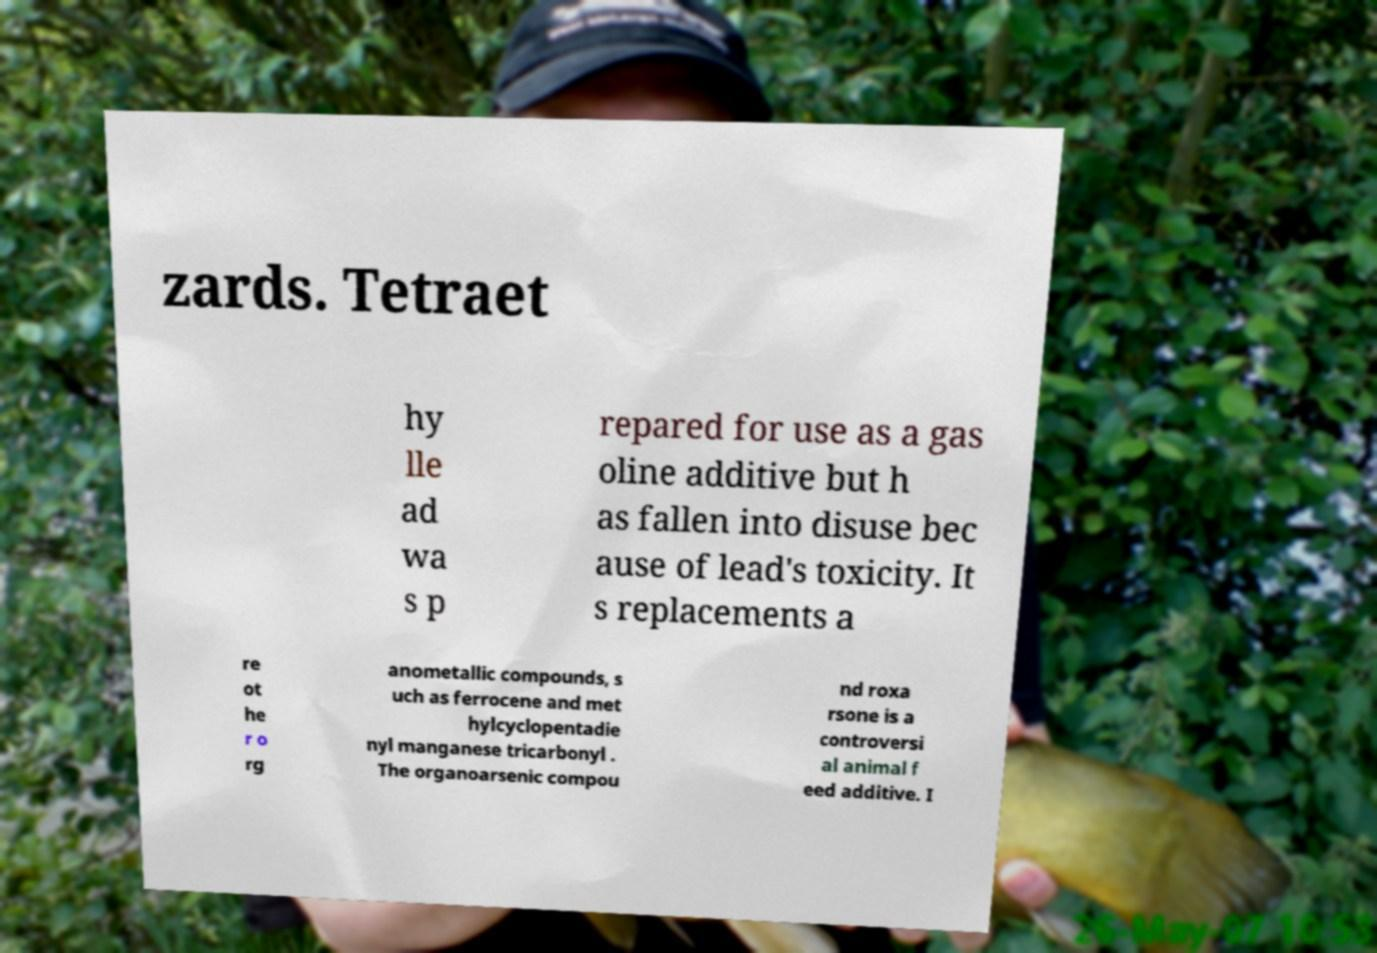I need the written content from this picture converted into text. Can you do that? zards. Tetraet hy lle ad wa s p repared for use as a gas oline additive but h as fallen into disuse bec ause of lead's toxicity. It s replacements a re ot he r o rg anometallic compounds, s uch as ferrocene and met hylcyclopentadie nyl manganese tricarbonyl . The organoarsenic compou nd roxa rsone is a controversi al animal f eed additive. I 